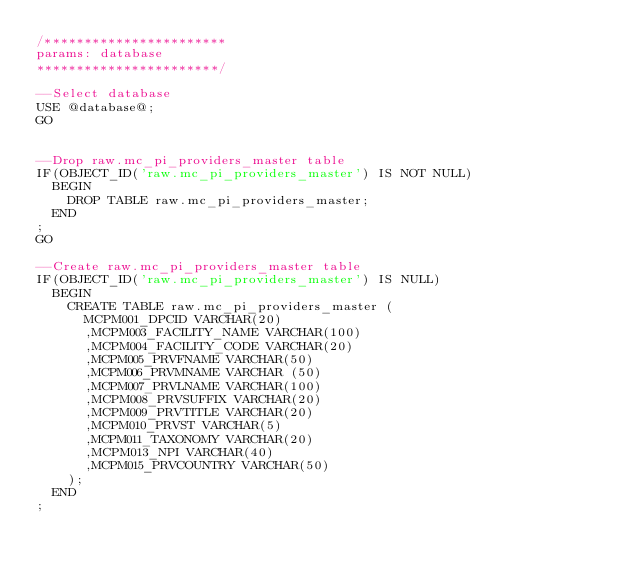<code> <loc_0><loc_0><loc_500><loc_500><_SQL_>/***********************
params: database
***********************/

--Select database
USE @database@;
GO


--Drop raw.mc_pi_providers_master table
IF(OBJECT_ID('raw.mc_pi_providers_master') IS NOT NULL)
  BEGIN
    DROP TABLE raw.mc_pi_providers_master;
  END
;
GO

--Create raw.mc_pi_providers_master table
IF(OBJECT_ID('raw.mc_pi_providers_master') IS NULL)
  BEGIN
    CREATE TABLE raw.mc_pi_providers_master (
      MCPM001_DPCID VARCHAR(20)
      ,MCPM003_FACILITY_NAME VARCHAR(100)
      ,MCPM004_FACILITY_CODE VARCHAR(20)
      ,MCPM005_PRVFNAME VARCHAR(50)
      ,MCPM006_PRVMNAME VARCHAR (50)
      ,MCPM007_PRVLNAME VARCHAR(100)
      ,MCPM008_PRVSUFFIX VARCHAR(20)
      ,MCPM009_PRVTITLE VARCHAR(20)
      ,MCPM010_PRVST VARCHAR(5)
      ,MCPM011_TAXONOMY VARCHAR(20)
      ,MCPM013_NPI VARCHAR(40)
      ,MCPM015_PRVCOUNTRY VARCHAR(50)
    );
  END
;</code> 